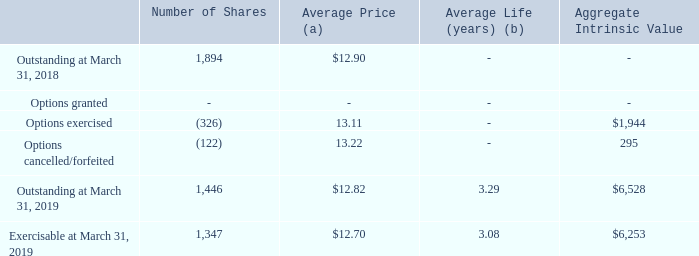Activity under our stock option plans is summarized as follows:
(a) Weighted-average exercise price
(b) Weighted-average contractual life remaining
The total aggregate intrinsic value of options exercised is $2,149, $1,724, and $1,944 for fiscal years ended March 31, 2017, 2018, and 2019, respectively.
What is the total aggregate intrinsic value of options exercised for the fiscal years ended March 31, 2017 to 2019 respectively? $2,149, $1,724, $1,944. What is the number of share options granted between March 31, 2018 and 2019 respectively? 0, 326. What is the number of shares outstanding at March 31, 2018 and 2019 respectively? 1,894, 1,446. What is the total aggregate intrinsic value of options exercised between 2017 to 2019? 2,149 + 1,724 + 1,944 
Answer: 5817. What is the percentage of total aggregate intrinsic value of options exercised as a percentage of the aggregate intrinsic value exercisable at March 31, 2019?
Answer scale should be: percent. 1,944/6,253 
Answer: 31.09. What is the percentage change in the average price between March 31, 2018 and 2019?
Answer scale should be: percent. (12.70 - 12.90)/12.90 
Answer: -1.55. 